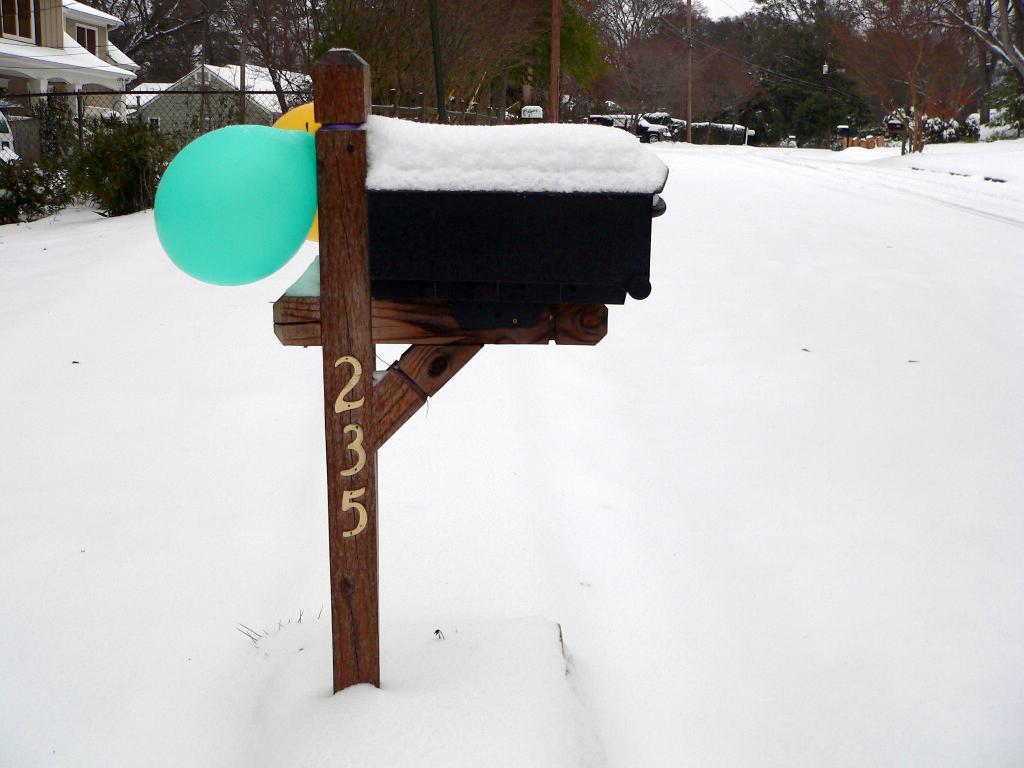What is on the stand in the image? There is snow on a stand in the image. How are the balloons related to the stand? The stand is tied with balloons. What type of structures can be seen in the background? There are houses with roofs visible in the background. What other elements can be seen in the background? There is a fence, trees, plants, a pole, wires, and the sky visible in the background. What type of acoustics can be heard from the owl in the image? There is no owl present in the image, so it is not possible to determine the acoustics of any owl. 